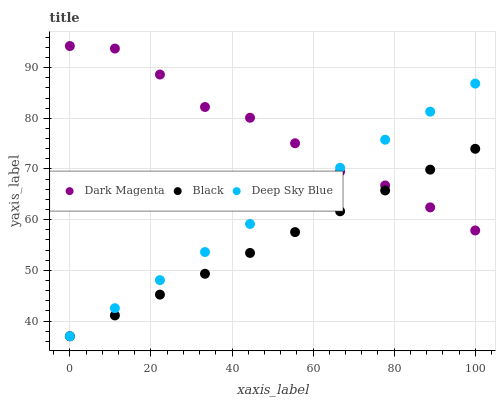Does Black have the minimum area under the curve?
Answer yes or no. Yes. Does Dark Magenta have the maximum area under the curve?
Answer yes or no. Yes. Does Deep Sky Blue have the minimum area under the curve?
Answer yes or no. No. Does Deep Sky Blue have the maximum area under the curve?
Answer yes or no. No. Is Black the smoothest?
Answer yes or no. Yes. Is Dark Magenta the roughest?
Answer yes or no. Yes. Is Deep Sky Blue the smoothest?
Answer yes or no. No. Is Deep Sky Blue the roughest?
Answer yes or no. No. Does Black have the lowest value?
Answer yes or no. Yes. Does Dark Magenta have the lowest value?
Answer yes or no. No. Does Dark Magenta have the highest value?
Answer yes or no. Yes. Does Deep Sky Blue have the highest value?
Answer yes or no. No. Does Black intersect Dark Magenta?
Answer yes or no. Yes. Is Black less than Dark Magenta?
Answer yes or no. No. Is Black greater than Dark Magenta?
Answer yes or no. No. 